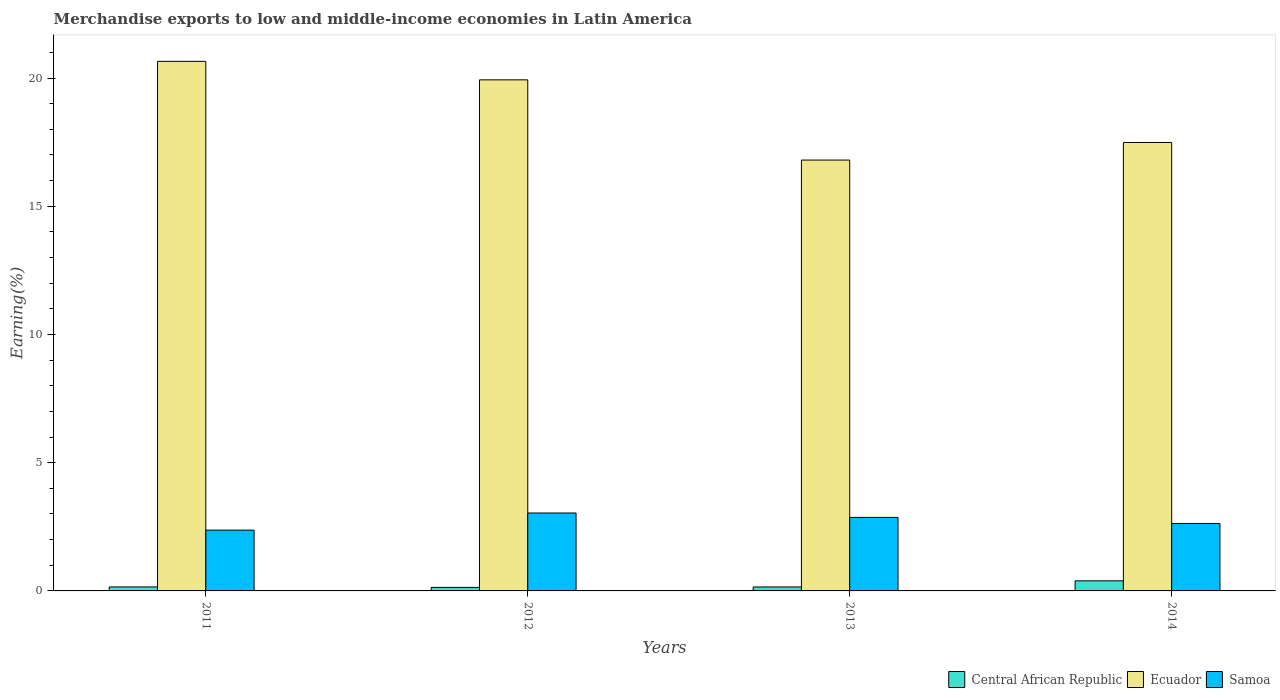How many different coloured bars are there?
Keep it short and to the point. 3. How many bars are there on the 2nd tick from the right?
Keep it short and to the point. 3. In how many cases, is the number of bars for a given year not equal to the number of legend labels?
Provide a succinct answer. 0. What is the percentage of amount earned from merchandise exports in Samoa in 2014?
Your response must be concise. 2.63. Across all years, what is the maximum percentage of amount earned from merchandise exports in Central African Republic?
Provide a succinct answer. 0.39. Across all years, what is the minimum percentage of amount earned from merchandise exports in Central African Republic?
Ensure brevity in your answer.  0.14. In which year was the percentage of amount earned from merchandise exports in Ecuador maximum?
Your response must be concise. 2011. What is the total percentage of amount earned from merchandise exports in Samoa in the graph?
Give a very brief answer. 10.9. What is the difference between the percentage of amount earned from merchandise exports in Ecuador in 2011 and that in 2014?
Offer a terse response. 3.16. What is the difference between the percentage of amount earned from merchandise exports in Samoa in 2011 and the percentage of amount earned from merchandise exports in Ecuador in 2014?
Ensure brevity in your answer.  -15.12. What is the average percentage of amount earned from merchandise exports in Samoa per year?
Your response must be concise. 2.73. In the year 2013, what is the difference between the percentage of amount earned from merchandise exports in Samoa and percentage of amount earned from merchandise exports in Central African Republic?
Give a very brief answer. 2.71. What is the ratio of the percentage of amount earned from merchandise exports in Central African Republic in 2012 to that in 2013?
Offer a terse response. 0.88. Is the difference between the percentage of amount earned from merchandise exports in Samoa in 2013 and 2014 greater than the difference between the percentage of amount earned from merchandise exports in Central African Republic in 2013 and 2014?
Your answer should be very brief. Yes. What is the difference between the highest and the second highest percentage of amount earned from merchandise exports in Ecuador?
Make the answer very short. 0.72. What is the difference between the highest and the lowest percentage of amount earned from merchandise exports in Samoa?
Offer a terse response. 0.67. What does the 3rd bar from the left in 2011 represents?
Offer a terse response. Samoa. What does the 2nd bar from the right in 2012 represents?
Make the answer very short. Ecuador. How many bars are there?
Your answer should be very brief. 12. Are all the bars in the graph horizontal?
Provide a short and direct response. No. How many years are there in the graph?
Your answer should be compact. 4. Does the graph contain grids?
Offer a terse response. No. What is the title of the graph?
Keep it short and to the point. Merchandise exports to low and middle-income economies in Latin America. What is the label or title of the X-axis?
Offer a terse response. Years. What is the label or title of the Y-axis?
Offer a terse response. Earning(%). What is the Earning(%) of Central African Republic in 2011?
Provide a short and direct response. 0.16. What is the Earning(%) in Ecuador in 2011?
Make the answer very short. 20.65. What is the Earning(%) in Samoa in 2011?
Provide a succinct answer. 2.37. What is the Earning(%) in Central African Republic in 2012?
Give a very brief answer. 0.14. What is the Earning(%) of Ecuador in 2012?
Ensure brevity in your answer.  19.93. What is the Earning(%) in Samoa in 2012?
Provide a succinct answer. 3.04. What is the Earning(%) of Central African Republic in 2013?
Your response must be concise. 0.15. What is the Earning(%) of Ecuador in 2013?
Ensure brevity in your answer.  16.8. What is the Earning(%) in Samoa in 2013?
Offer a terse response. 2.87. What is the Earning(%) in Central African Republic in 2014?
Give a very brief answer. 0.39. What is the Earning(%) of Ecuador in 2014?
Your response must be concise. 17.49. What is the Earning(%) in Samoa in 2014?
Make the answer very short. 2.63. Across all years, what is the maximum Earning(%) in Central African Republic?
Make the answer very short. 0.39. Across all years, what is the maximum Earning(%) of Ecuador?
Give a very brief answer. 20.65. Across all years, what is the maximum Earning(%) in Samoa?
Offer a very short reply. 3.04. Across all years, what is the minimum Earning(%) in Central African Republic?
Make the answer very short. 0.14. Across all years, what is the minimum Earning(%) in Ecuador?
Ensure brevity in your answer.  16.8. Across all years, what is the minimum Earning(%) in Samoa?
Ensure brevity in your answer.  2.37. What is the total Earning(%) of Central African Republic in the graph?
Your answer should be compact. 0.84. What is the total Earning(%) in Ecuador in the graph?
Ensure brevity in your answer.  74.86. What is the total Earning(%) of Samoa in the graph?
Your answer should be compact. 10.9. What is the difference between the Earning(%) in Central African Republic in 2011 and that in 2012?
Make the answer very short. 0.02. What is the difference between the Earning(%) in Ecuador in 2011 and that in 2012?
Give a very brief answer. 0.72. What is the difference between the Earning(%) in Samoa in 2011 and that in 2012?
Make the answer very short. -0.67. What is the difference between the Earning(%) of Ecuador in 2011 and that in 2013?
Provide a succinct answer. 3.85. What is the difference between the Earning(%) of Samoa in 2011 and that in 2013?
Offer a terse response. -0.5. What is the difference between the Earning(%) in Central African Republic in 2011 and that in 2014?
Make the answer very short. -0.24. What is the difference between the Earning(%) of Ecuador in 2011 and that in 2014?
Your answer should be compact. 3.16. What is the difference between the Earning(%) in Samoa in 2011 and that in 2014?
Offer a very short reply. -0.26. What is the difference between the Earning(%) in Central African Republic in 2012 and that in 2013?
Ensure brevity in your answer.  -0.02. What is the difference between the Earning(%) in Ecuador in 2012 and that in 2013?
Your answer should be compact. 3.13. What is the difference between the Earning(%) of Samoa in 2012 and that in 2013?
Your answer should be compact. 0.17. What is the difference between the Earning(%) of Central African Republic in 2012 and that in 2014?
Give a very brief answer. -0.26. What is the difference between the Earning(%) of Ecuador in 2012 and that in 2014?
Provide a succinct answer. 2.44. What is the difference between the Earning(%) in Samoa in 2012 and that in 2014?
Your response must be concise. 0.41. What is the difference between the Earning(%) in Central African Republic in 2013 and that in 2014?
Your answer should be very brief. -0.24. What is the difference between the Earning(%) of Ecuador in 2013 and that in 2014?
Offer a very short reply. -0.69. What is the difference between the Earning(%) in Samoa in 2013 and that in 2014?
Offer a terse response. 0.24. What is the difference between the Earning(%) of Central African Republic in 2011 and the Earning(%) of Ecuador in 2012?
Ensure brevity in your answer.  -19.77. What is the difference between the Earning(%) of Central African Republic in 2011 and the Earning(%) of Samoa in 2012?
Offer a very short reply. -2.88. What is the difference between the Earning(%) in Ecuador in 2011 and the Earning(%) in Samoa in 2012?
Offer a very short reply. 17.61. What is the difference between the Earning(%) of Central African Republic in 2011 and the Earning(%) of Ecuador in 2013?
Your answer should be compact. -16.64. What is the difference between the Earning(%) of Central African Republic in 2011 and the Earning(%) of Samoa in 2013?
Your answer should be compact. -2.71. What is the difference between the Earning(%) of Ecuador in 2011 and the Earning(%) of Samoa in 2013?
Your answer should be compact. 17.78. What is the difference between the Earning(%) in Central African Republic in 2011 and the Earning(%) in Ecuador in 2014?
Offer a very short reply. -17.33. What is the difference between the Earning(%) of Central African Republic in 2011 and the Earning(%) of Samoa in 2014?
Keep it short and to the point. -2.47. What is the difference between the Earning(%) in Ecuador in 2011 and the Earning(%) in Samoa in 2014?
Your response must be concise. 18.02. What is the difference between the Earning(%) of Central African Republic in 2012 and the Earning(%) of Ecuador in 2013?
Your answer should be very brief. -16.66. What is the difference between the Earning(%) of Central African Republic in 2012 and the Earning(%) of Samoa in 2013?
Your response must be concise. -2.73. What is the difference between the Earning(%) in Ecuador in 2012 and the Earning(%) in Samoa in 2013?
Give a very brief answer. 17.06. What is the difference between the Earning(%) of Central African Republic in 2012 and the Earning(%) of Ecuador in 2014?
Offer a very short reply. -17.35. What is the difference between the Earning(%) in Central African Republic in 2012 and the Earning(%) in Samoa in 2014?
Provide a short and direct response. -2.49. What is the difference between the Earning(%) of Ecuador in 2012 and the Earning(%) of Samoa in 2014?
Offer a very short reply. 17.3. What is the difference between the Earning(%) in Central African Republic in 2013 and the Earning(%) in Ecuador in 2014?
Offer a very short reply. -17.33. What is the difference between the Earning(%) of Central African Republic in 2013 and the Earning(%) of Samoa in 2014?
Ensure brevity in your answer.  -2.48. What is the difference between the Earning(%) of Ecuador in 2013 and the Earning(%) of Samoa in 2014?
Your answer should be very brief. 14.17. What is the average Earning(%) in Central African Republic per year?
Offer a very short reply. 0.21. What is the average Earning(%) in Ecuador per year?
Keep it short and to the point. 18.72. What is the average Earning(%) in Samoa per year?
Your answer should be very brief. 2.73. In the year 2011, what is the difference between the Earning(%) of Central African Republic and Earning(%) of Ecuador?
Provide a succinct answer. -20.49. In the year 2011, what is the difference between the Earning(%) in Central African Republic and Earning(%) in Samoa?
Offer a terse response. -2.21. In the year 2011, what is the difference between the Earning(%) in Ecuador and Earning(%) in Samoa?
Your answer should be very brief. 18.28. In the year 2012, what is the difference between the Earning(%) in Central African Republic and Earning(%) in Ecuador?
Offer a very short reply. -19.79. In the year 2012, what is the difference between the Earning(%) of Central African Republic and Earning(%) of Samoa?
Offer a very short reply. -2.9. In the year 2012, what is the difference between the Earning(%) of Ecuador and Earning(%) of Samoa?
Make the answer very short. 16.89. In the year 2013, what is the difference between the Earning(%) of Central African Republic and Earning(%) of Ecuador?
Provide a succinct answer. -16.65. In the year 2013, what is the difference between the Earning(%) in Central African Republic and Earning(%) in Samoa?
Your answer should be very brief. -2.71. In the year 2013, what is the difference between the Earning(%) of Ecuador and Earning(%) of Samoa?
Your answer should be very brief. 13.93. In the year 2014, what is the difference between the Earning(%) of Central African Republic and Earning(%) of Ecuador?
Give a very brief answer. -17.09. In the year 2014, what is the difference between the Earning(%) in Central African Republic and Earning(%) in Samoa?
Ensure brevity in your answer.  -2.24. In the year 2014, what is the difference between the Earning(%) in Ecuador and Earning(%) in Samoa?
Ensure brevity in your answer.  14.86. What is the ratio of the Earning(%) of Central African Republic in 2011 to that in 2012?
Give a very brief answer. 1.14. What is the ratio of the Earning(%) of Ecuador in 2011 to that in 2012?
Your answer should be very brief. 1.04. What is the ratio of the Earning(%) in Samoa in 2011 to that in 2012?
Offer a terse response. 0.78. What is the ratio of the Earning(%) in Central African Republic in 2011 to that in 2013?
Offer a terse response. 1.01. What is the ratio of the Earning(%) in Ecuador in 2011 to that in 2013?
Ensure brevity in your answer.  1.23. What is the ratio of the Earning(%) in Samoa in 2011 to that in 2013?
Offer a very short reply. 0.83. What is the ratio of the Earning(%) in Central African Republic in 2011 to that in 2014?
Make the answer very short. 0.4. What is the ratio of the Earning(%) of Ecuador in 2011 to that in 2014?
Your response must be concise. 1.18. What is the ratio of the Earning(%) in Samoa in 2011 to that in 2014?
Provide a short and direct response. 0.9. What is the ratio of the Earning(%) of Central African Republic in 2012 to that in 2013?
Your response must be concise. 0.88. What is the ratio of the Earning(%) in Ecuador in 2012 to that in 2013?
Your answer should be very brief. 1.19. What is the ratio of the Earning(%) in Samoa in 2012 to that in 2013?
Give a very brief answer. 1.06. What is the ratio of the Earning(%) in Central African Republic in 2012 to that in 2014?
Your response must be concise. 0.35. What is the ratio of the Earning(%) in Ecuador in 2012 to that in 2014?
Make the answer very short. 1.14. What is the ratio of the Earning(%) in Samoa in 2012 to that in 2014?
Your answer should be very brief. 1.16. What is the ratio of the Earning(%) of Central African Republic in 2013 to that in 2014?
Give a very brief answer. 0.39. What is the ratio of the Earning(%) of Ecuador in 2013 to that in 2014?
Offer a very short reply. 0.96. What is the ratio of the Earning(%) of Samoa in 2013 to that in 2014?
Offer a very short reply. 1.09. What is the difference between the highest and the second highest Earning(%) of Central African Republic?
Your response must be concise. 0.24. What is the difference between the highest and the second highest Earning(%) of Ecuador?
Make the answer very short. 0.72. What is the difference between the highest and the second highest Earning(%) in Samoa?
Provide a short and direct response. 0.17. What is the difference between the highest and the lowest Earning(%) in Central African Republic?
Keep it short and to the point. 0.26. What is the difference between the highest and the lowest Earning(%) of Ecuador?
Ensure brevity in your answer.  3.85. What is the difference between the highest and the lowest Earning(%) of Samoa?
Provide a succinct answer. 0.67. 